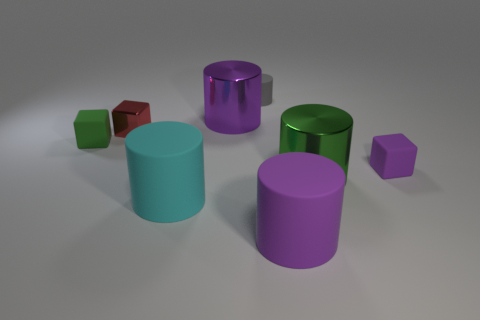Subtract all tiny red blocks. How many blocks are left? 2 Add 1 small brown rubber things. How many objects exist? 9 Subtract all purple balls. How many purple cylinders are left? 2 Subtract 2 cylinders. How many cylinders are left? 3 Subtract all gray cylinders. How many cylinders are left? 4 Subtract all cylinders. How many objects are left? 3 Subtract all green shiny cylinders. Subtract all small gray things. How many objects are left? 6 Add 7 purple shiny things. How many purple shiny things are left? 8 Add 8 large blue rubber balls. How many large blue rubber balls exist? 8 Subtract 1 green blocks. How many objects are left? 7 